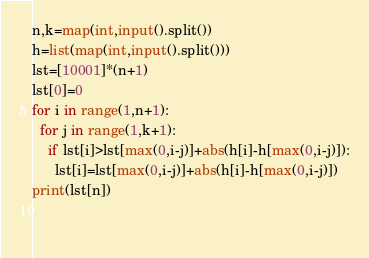Convert code to text. <code><loc_0><loc_0><loc_500><loc_500><_Python_>n,k=map(int,input().split())
h=list(map(int,input().split()))
lst=[10001]*(n+1)
lst[0]=0
for i in range(1,n+1):
  for j in range(1,k+1):
    if lst[i]>lst[max(0,i-j)]+abs(h[i]-h[max(0,i-j)]):
      lst[i]=lst[max(0,i-j)]+abs(h[i]-h[max(0,i-j)])
print(lst[n])
    
  
</code> 